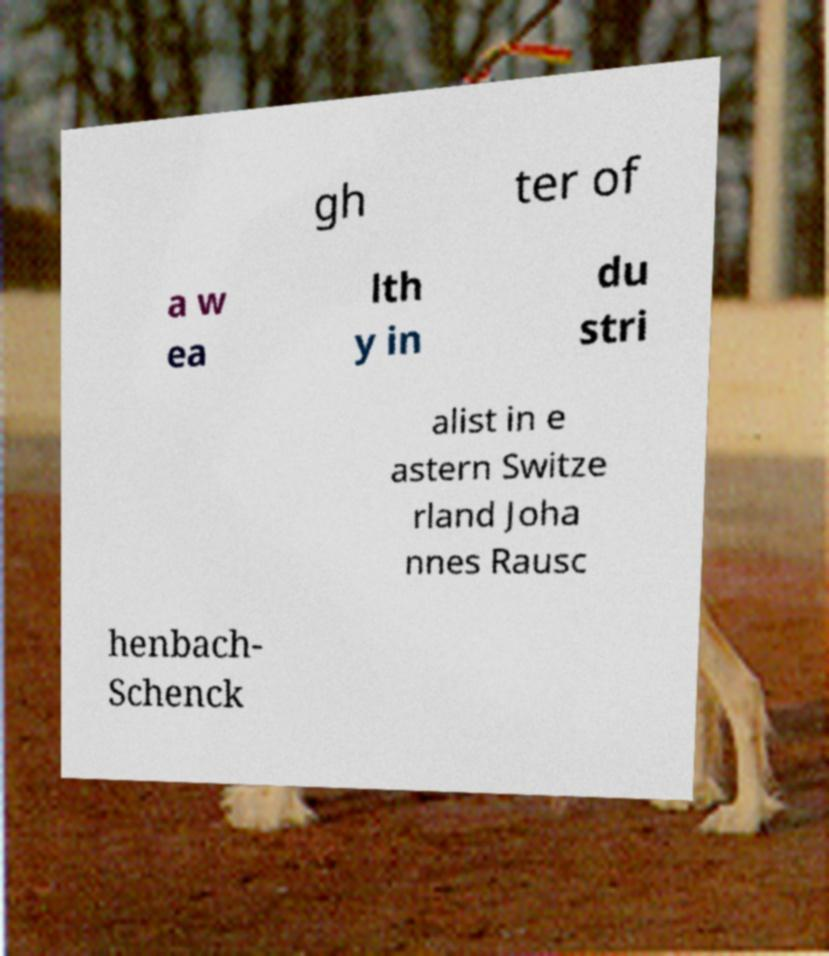Can you accurately transcribe the text from the provided image for me? gh ter of a w ea lth y in du stri alist in e astern Switze rland Joha nnes Rausc henbach- Schenck 